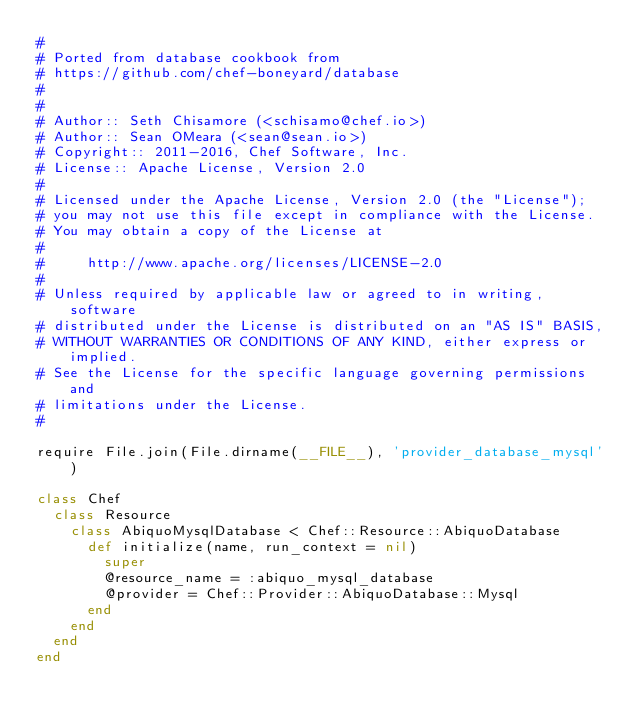<code> <loc_0><loc_0><loc_500><loc_500><_Ruby_>#
# Ported from database cookbook from
# https://github.com/chef-boneyard/database
#
#
# Author:: Seth Chisamore (<schisamo@chef.io>)
# Author:: Sean OMeara (<sean@sean.io>)
# Copyright:: 2011-2016, Chef Software, Inc.
# License:: Apache License, Version 2.0
#
# Licensed under the Apache License, Version 2.0 (the "License");
# you may not use this file except in compliance with the License.
# You may obtain a copy of the License at
#
#     http://www.apache.org/licenses/LICENSE-2.0
#
# Unless required by applicable law or agreed to in writing, software
# distributed under the License is distributed on an "AS IS" BASIS,
# WITHOUT WARRANTIES OR CONDITIONS OF ANY KIND, either express or implied.
# See the License for the specific language governing permissions and
# limitations under the License.
#

require File.join(File.dirname(__FILE__), 'provider_database_mysql')

class Chef
  class Resource
    class AbiquoMysqlDatabase < Chef::Resource::AbiquoDatabase
      def initialize(name, run_context = nil)
        super
        @resource_name = :abiquo_mysql_database
        @provider = Chef::Provider::AbiquoDatabase::Mysql
      end
    end
  end
end
</code> 